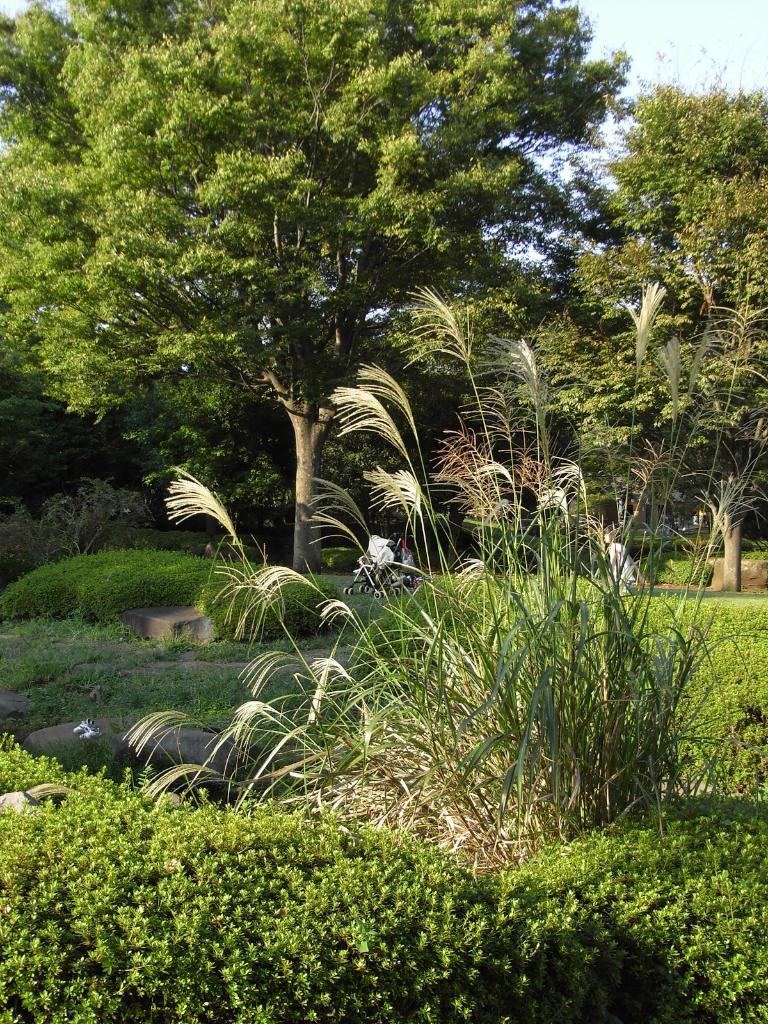Describe this image in one or two sentences. In this image there is a garden, in the background there are trees and a sky. 